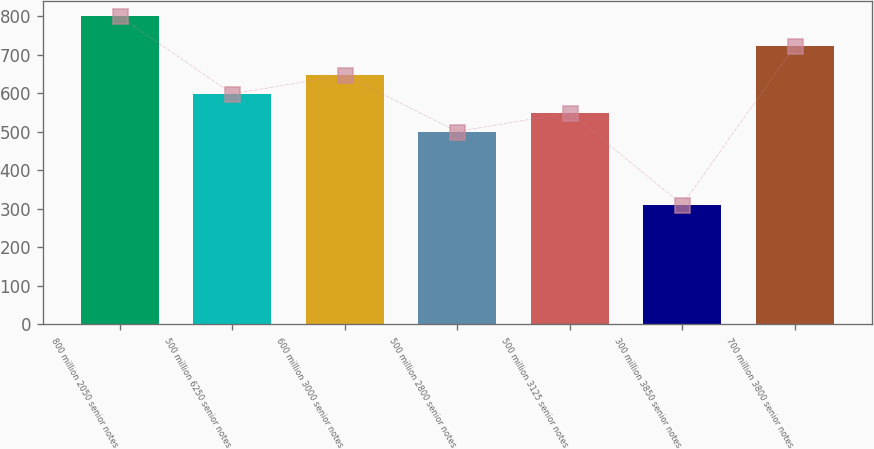<chart> <loc_0><loc_0><loc_500><loc_500><bar_chart><fcel>800 million 2050 senior notes<fcel>500 million 6250 senior notes<fcel>600 million 3000 senior notes<fcel>500 million 2800 senior notes<fcel>500 million 3125 senior notes<fcel>300 million 3850 senior notes<fcel>700 million 3800 senior notes<nl><fcel>800<fcel>598.8<fcel>647.7<fcel>501<fcel>549.9<fcel>311<fcel>723<nl></chart> 